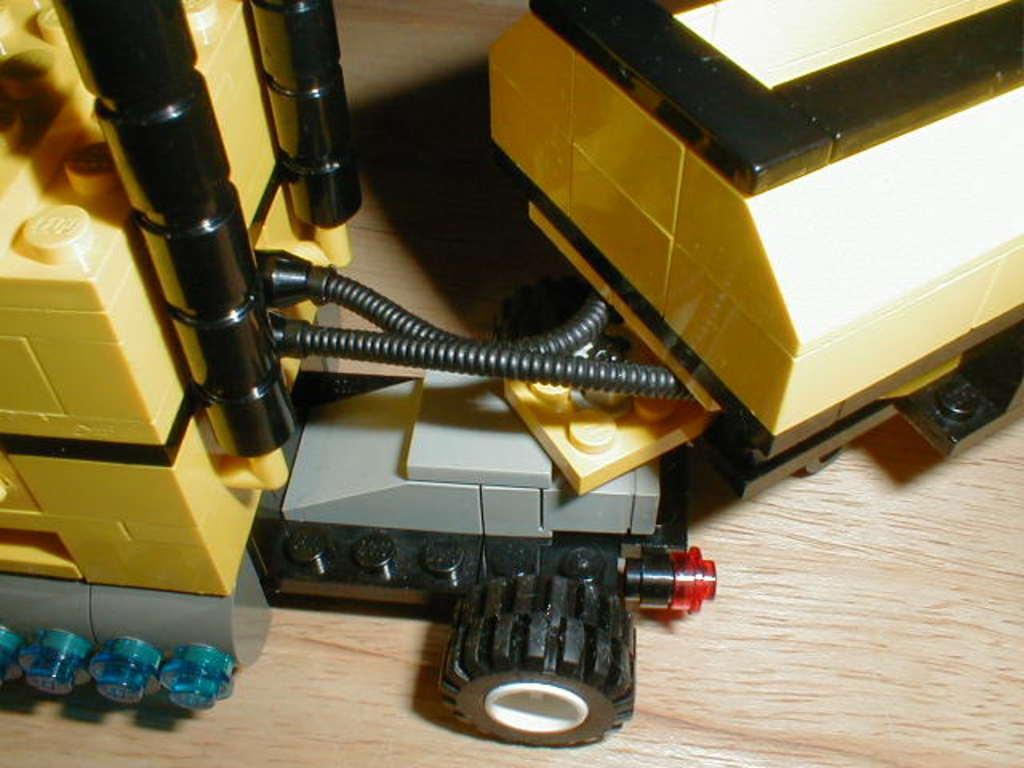How would you summarize this image in a sentence or two? In this image there are lego toys. There is a trolley which is made up of lego toys. 